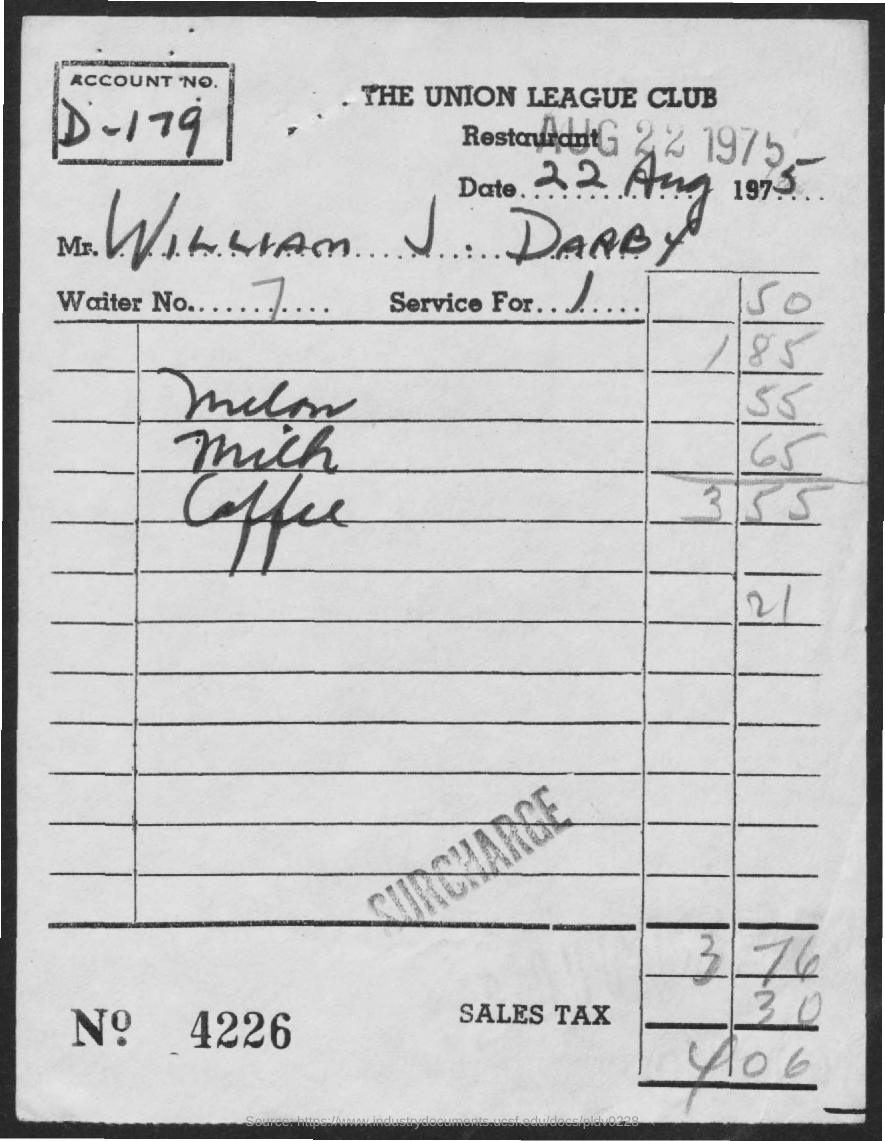What is the Account No. given in the bill?
Provide a short and direct response. D-179. What is the Waiter No. given in the bill?
Offer a terse response. 7. Which restaurant's bill is given here?
Your answer should be compact. The union league club restaurant. 